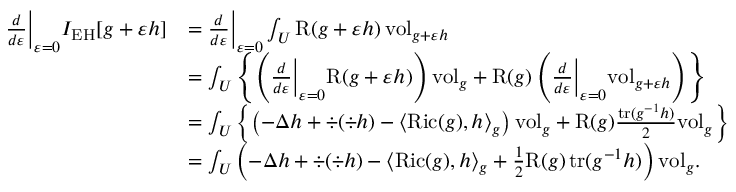Convert formula to latex. <formula><loc_0><loc_0><loc_500><loc_500>\begin{array} { r l } { \frac { d } { d \varepsilon } \left | _ { \varepsilon = 0 } I _ { E H } [ g + \varepsilon h ] } & { = \frac { d } { d \varepsilon } \right | _ { \varepsilon = 0 } \int _ { U } R ( g + \varepsilon h ) \, v o l _ { g + \varepsilon h } } \\ & { = \int _ { U } \left \{ \left ( \frac { d } { d \varepsilon } \left | _ { \varepsilon = 0 } R ( g + \varepsilon h ) \right ) v o l _ { g } + R ( g ) \left ( \frac { d } { d \varepsilon } \right | _ { \varepsilon = 0 } v o l _ { g + \varepsilon h } \right ) \right \} } \\ & { = \int _ { U } \left \{ \left ( - \Delta h + \div ( \div h ) - \langle R i c ( g ) , h \rangle _ { g } \right ) v o l _ { g } + R ( g ) \frac { t r ( g ^ { - 1 } h ) } { 2 } v o l _ { g } \right \} } \\ & { = \int _ { U } \left ( - \Delta h + \div ( \div h ) - \langle R i c ( g ) , h \rangle _ { g } + \frac { 1 } { 2 } R ( g ) \, t r ( g ^ { - 1 } h ) \right ) v o l _ { g } . } \end{array}</formula> 